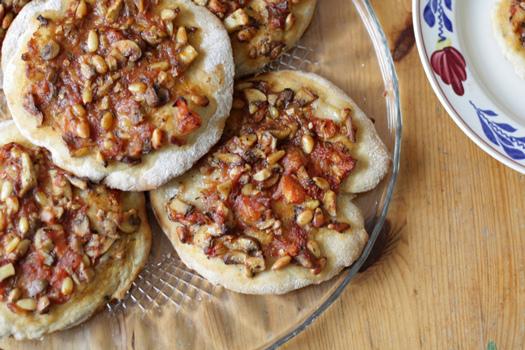What kind of desert is this?
Answer briefly. Cookie. What color is the platter?
Quick response, please. Clear. Is the food sweet?
Give a very brief answer. Yes. 